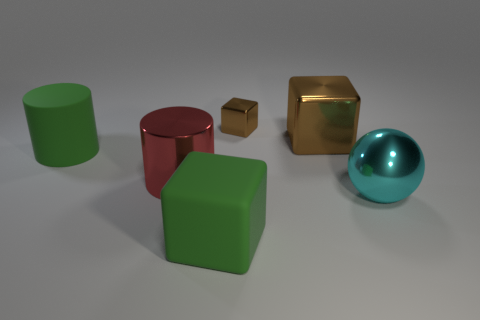Add 2 large cylinders. How many objects exist? 8 Subtract all balls. How many objects are left? 5 Add 3 red cylinders. How many red cylinders are left? 4 Add 2 big red cylinders. How many big red cylinders exist? 3 Subtract 0 purple blocks. How many objects are left? 6 Subtract all small yellow metallic cylinders. Subtract all small things. How many objects are left? 5 